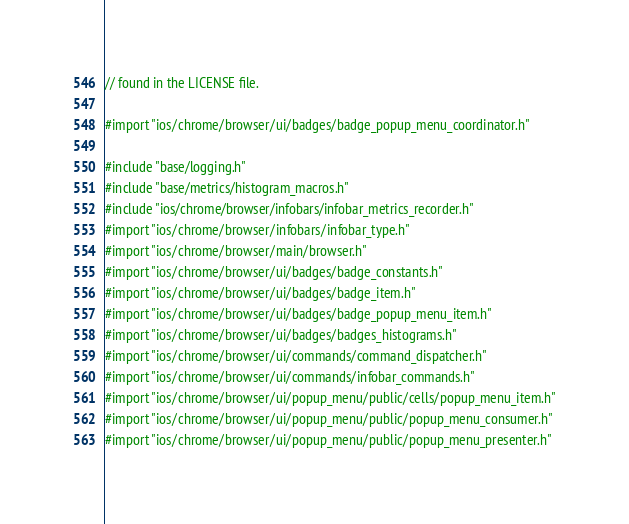<code> <loc_0><loc_0><loc_500><loc_500><_ObjectiveC_>// found in the LICENSE file.

#import "ios/chrome/browser/ui/badges/badge_popup_menu_coordinator.h"

#include "base/logging.h"
#include "base/metrics/histogram_macros.h"
#include "ios/chrome/browser/infobars/infobar_metrics_recorder.h"
#import "ios/chrome/browser/infobars/infobar_type.h"
#import "ios/chrome/browser/main/browser.h"
#import "ios/chrome/browser/ui/badges/badge_constants.h"
#import "ios/chrome/browser/ui/badges/badge_item.h"
#import "ios/chrome/browser/ui/badges/badge_popup_menu_item.h"
#import "ios/chrome/browser/ui/badges/badges_histograms.h"
#import "ios/chrome/browser/ui/commands/command_dispatcher.h"
#import "ios/chrome/browser/ui/commands/infobar_commands.h"
#import "ios/chrome/browser/ui/popup_menu/public/cells/popup_menu_item.h"
#import "ios/chrome/browser/ui/popup_menu/public/popup_menu_consumer.h"
#import "ios/chrome/browser/ui/popup_menu/public/popup_menu_presenter.h"</code> 